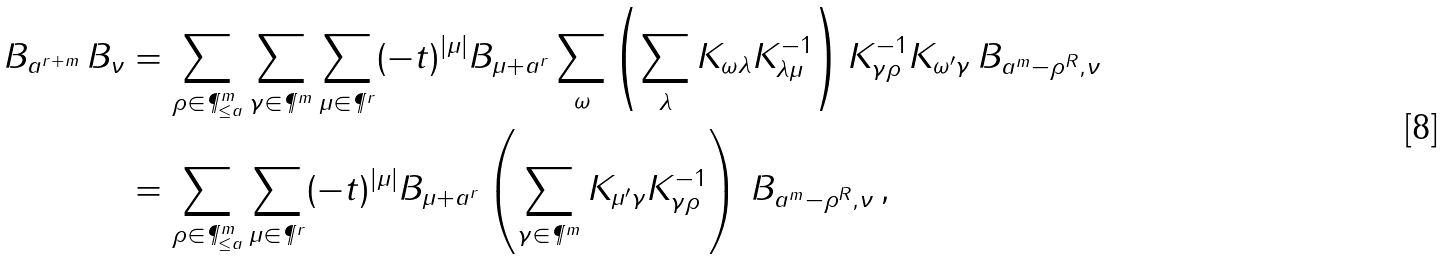Convert formula to latex. <formula><loc_0><loc_0><loc_500><loc_500>B _ { a ^ { r + m } } \, B _ { \nu } & = \sum _ { \rho \in \P ^ { m } _ { \leq a } } \sum _ { \gamma \in \P ^ { m } } \sum _ { \mu \in \P ^ { r } } ( - t ) ^ { | \mu | } B _ { \mu + a ^ { r } } \sum _ { \omega } \left ( \sum _ { \lambda } K _ { \omega \lambda } K _ { \lambda \mu } ^ { - 1 } \right ) K _ { \gamma \rho } ^ { - 1 } K _ { \omega ^ { \prime } \gamma } \, B _ { a ^ { m } - \rho ^ { R } , \nu } \\ & = \sum _ { \rho \in \P ^ { m } _ { \leq a } } \sum _ { \mu \in \P ^ { r } } ( - t ) ^ { | \mu | } B _ { \mu + a ^ { r } } \left ( \sum _ { \gamma \in \P ^ { m } } K _ { \mu ^ { \prime } \gamma } K _ { \gamma \rho } ^ { - 1 } \right ) \, B _ { a ^ { m } - \rho ^ { R } , \nu } \, ,</formula> 